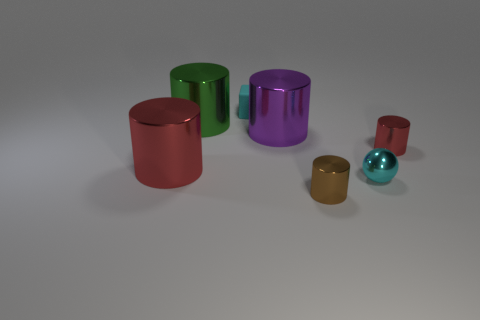Are there fewer large red cylinders on the right side of the tiny brown metal cylinder than cyan rubber objects that are in front of the small red metallic thing?
Offer a terse response. No. What is the shape of the cyan thing behind the cyan metal sphere?
Provide a short and direct response. Cube. Is the material of the green thing the same as the small cube?
Provide a short and direct response. No. Are there any other things that are the same material as the tiny block?
Offer a very short reply. No. Are there fewer brown shiny objects that are to the left of the brown metallic object than green metal objects?
Ensure brevity in your answer.  Yes. What number of tiny shiny cylinders are left of the rubber object?
Provide a succinct answer. 0. There is a large metallic thing to the right of the small cyan rubber thing; is its shape the same as the red thing right of the brown cylinder?
Provide a short and direct response. Yes. The thing that is both left of the tiny cyan block and right of the big red metal thing has what shape?
Keep it short and to the point. Cylinder. What is the size of the green thing that is made of the same material as the small brown thing?
Keep it short and to the point. Large. Are there fewer tiny cyan shiny objects than big blue matte things?
Ensure brevity in your answer.  No. 